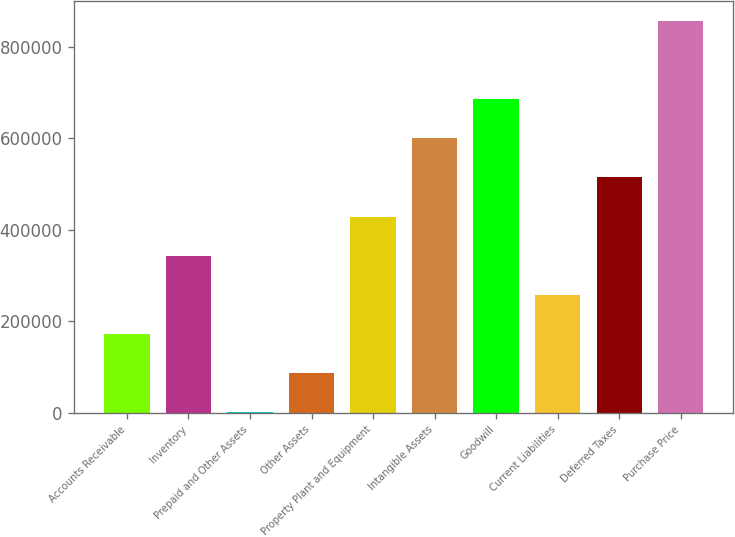Convert chart. <chart><loc_0><loc_0><loc_500><loc_500><bar_chart><fcel>Accounts Receivable<fcel>Inventory<fcel>Prepaid and Other Assets<fcel>Other Assets<fcel>Property Plant and Equipment<fcel>Intangible Assets<fcel>Goodwill<fcel>Current Liabilities<fcel>Deferred Taxes<fcel>Purchase Price<nl><fcel>172176<fcel>343472<fcel>881<fcel>86528.7<fcel>429120<fcel>600415<fcel>686063<fcel>257824<fcel>514767<fcel>857358<nl></chart> 